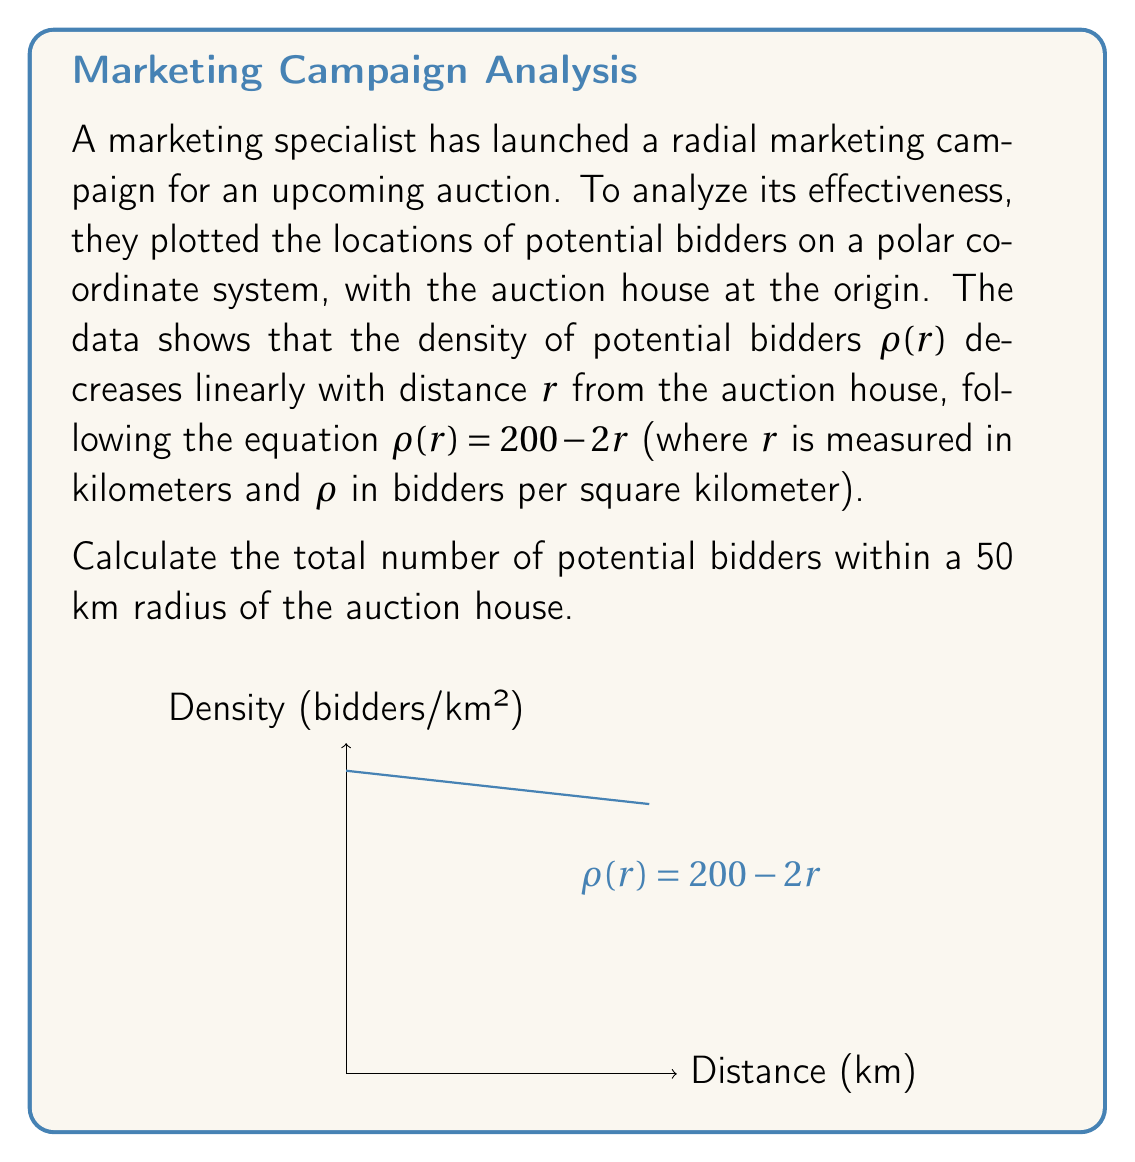Solve this math problem. To solve this problem, we need to integrate the density function over the given area. In polar coordinates, the area element is $r dr d\theta$, and we need to integrate over $r$ from 0 to 50 km and $\theta$ from 0 to $2\pi$.

Step 1: Set up the double integral
$$ N = \int_0^{2\pi} \int_0^{50} \rho(r) \cdot r \, dr \, d\theta $$

Step 2: Substitute the density function
$$ N = \int_0^{2\pi} \int_0^{50} (200 - 2r) \cdot r \, dr \, d\theta $$

Step 3: Integrate with respect to r
$$ N = \int_0^{2\pi} \left[ 100r^2 - \frac{2}{3}r^3 \right]_0^{50} \, d\theta $$

Step 4: Evaluate the inner integral
$$ N = \int_0^{2\pi} \left( 250000 - \frac{250000}{3} \right) \, d\theta = \int_0^{2\pi} \frac{500000}{3} \, d\theta $$

Step 5: Integrate with respect to θ
$$ N = \frac{500000}{3} \cdot 2\pi = \frac{1000000\pi}{3} $$

Therefore, the total number of potential bidders within a 50 km radius is approximately 1,047,198.
Answer: $\frac{1000000\pi}{3} \approx 1,047,198$ potential bidders 